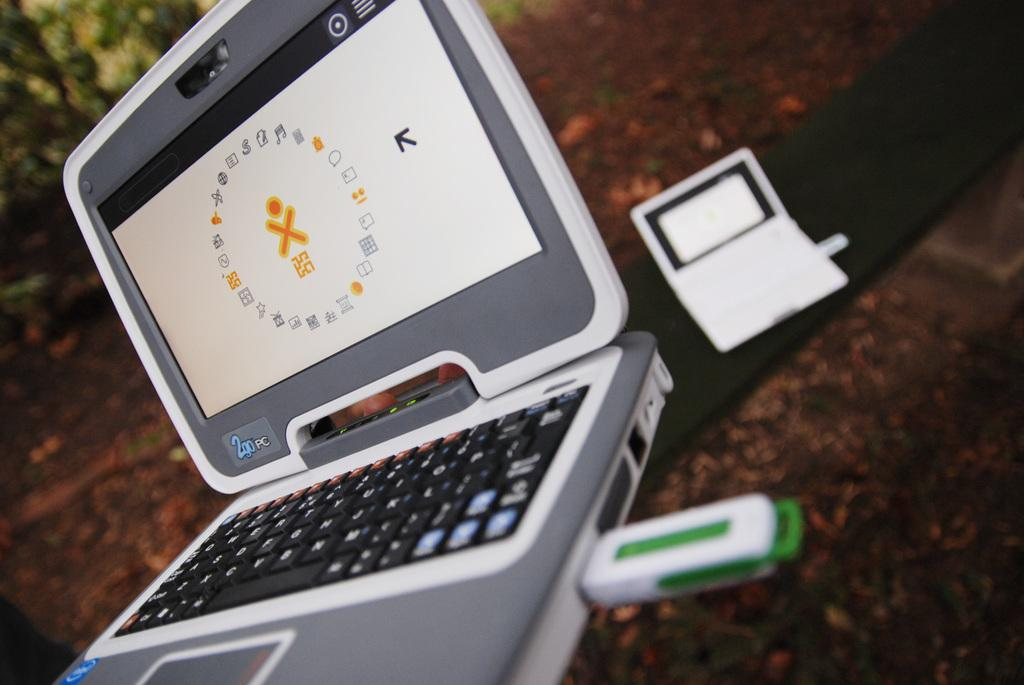<image>
Create a compact narrative representing the image presented. A 2Go PC sits open on a table with a flash drive inserted into it. 